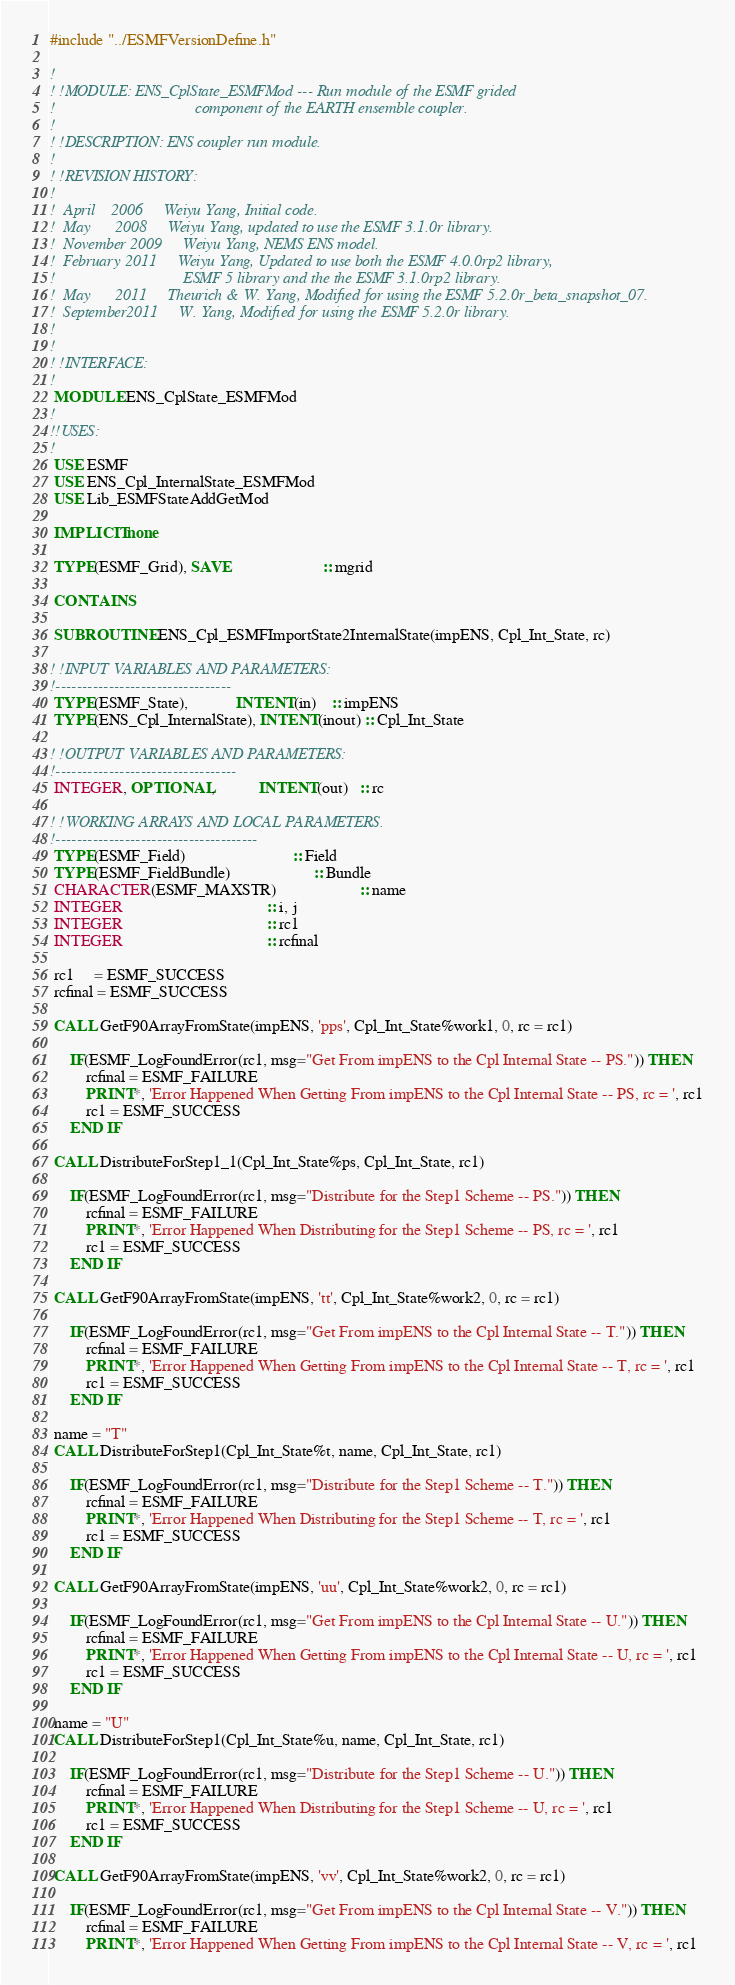Convert code to text. <code><loc_0><loc_0><loc_500><loc_500><_FORTRAN_>#include "../ESMFVersionDefine.h"

!
! !MODULE: ENS_CplState_ESMFMod --- Run module of the ESMF grided
!                                   component of the EARTH ensemble coupler.
!
! !DESCRIPTION: ENS coupler run module.
!
! !REVISION HISTORY:
!
!  April    2006     Weiyu Yang, Initial code.
!  May      2008     Weiyu Yang, updated to use the ESMF 3.1.0r library.
!  November 2009     Weiyu Yang, NEMS ENS model.
!  February 2011     Weiyu Yang, Updated to use both the ESMF 4.0.0rp2 library,
!                                ESMF 5 library and the the ESMF 3.1.0rp2 library.
!  May      2011     Theurich & W. Yang, Modified for using the ESMF 5.2.0r_beta_snapshot_07.
!  September2011     W. Yang, Modified for using the ESMF 5.2.0r library.
!
!
! !INTERFACE:
!
 MODULE ENS_CplState_ESMFMod
!
!!USES:
!
 USE ESMF
 USE ENS_Cpl_InternalState_ESMFMod
 USE Lib_ESMFStateAddGetMod

 IMPLICIT none

 TYPE(ESMF_Grid), SAVE                       :: mgrid

 CONTAINS

 SUBROUTINE ENS_Cpl_ESMFImportState2InternalState(impENS, Cpl_Int_State, rc)

! !INPUT VARIABLES AND PARAMETERS:
!---------------------------------
 TYPE(ESMF_State),            INTENT(in)    :: impENS
 TYPE(ENS_Cpl_InternalState), INTENT(inout) :: Cpl_Int_State

! !OUTPUT VARIABLES AND PARAMETERS:
!----------------------------------
 INTEGER, OPTIONAL,           INTENT(out)   :: rc

! !WORKING ARRAYS AND LOCAL PARAMETERS.
!--------------------------------------
 TYPE(ESMF_Field)                           :: Field
 TYPE(ESMF_FieldBundle)                     :: Bundle
 CHARACTER(ESMF_MAXSTR)                     :: name
 INTEGER                                    :: i, j
 INTEGER                                    :: rc1
 INTEGER                                    :: rcfinal

 rc1     = ESMF_SUCCESS
 rcfinal = ESMF_SUCCESS

 CALL GetF90ArrayFromState(impENS, 'pps', Cpl_Int_State%work1, 0, rc = rc1)

     IF(ESMF_LogFoundError(rc1, msg="Get From impENS to the Cpl Internal State -- PS.")) THEN
         rcfinal = ESMF_FAILURE
         PRINT*, 'Error Happened When Getting From impENS to the Cpl Internal State -- PS, rc = ', rc1
         rc1 = ESMF_SUCCESS
     END IF

 CALL DistributeForStep1_1(Cpl_Int_State%ps, Cpl_Int_State, rc1)

     IF(ESMF_LogFoundError(rc1, msg="Distribute for the Step1 Scheme -- PS.")) THEN
         rcfinal = ESMF_FAILURE
         PRINT*, 'Error Happened When Distributing for the Step1 Scheme -- PS, rc = ', rc1
         rc1 = ESMF_SUCCESS
     END IF

 CALL GetF90ArrayFromState(impENS, 'tt', Cpl_Int_State%work2, 0, rc = rc1)

     IF(ESMF_LogFoundError(rc1, msg="Get From impENS to the Cpl Internal State -- T.")) THEN
         rcfinal = ESMF_FAILURE
         PRINT*, 'Error Happened When Getting From impENS to the Cpl Internal State -- T, rc = ', rc1
         rc1 = ESMF_SUCCESS
     END IF

 name = "T"
 CALL DistributeForStep1(Cpl_Int_State%t, name, Cpl_Int_State, rc1)

     IF(ESMF_LogFoundError(rc1, msg="Distribute for the Step1 Scheme -- T.")) THEN
         rcfinal = ESMF_FAILURE
         PRINT*, 'Error Happened When Distributing for the Step1 Scheme -- T, rc = ', rc1
         rc1 = ESMF_SUCCESS
     END IF

 CALL GetF90ArrayFromState(impENS, 'uu', Cpl_Int_State%work2, 0, rc = rc1)

     IF(ESMF_LogFoundError(rc1, msg="Get From impENS to the Cpl Internal State -- U.")) THEN
         rcfinal = ESMF_FAILURE
         PRINT*, 'Error Happened When Getting From impENS to the Cpl Internal State -- U, rc = ', rc1
         rc1 = ESMF_SUCCESS
     END IF

 name = "U"
 CALL DistributeForStep1(Cpl_Int_State%u, name, Cpl_Int_State, rc1)

     IF(ESMF_LogFoundError(rc1, msg="Distribute for the Step1 Scheme -- U.")) THEN
         rcfinal = ESMF_FAILURE
         PRINT*, 'Error Happened When Distributing for the Step1 Scheme -- U, rc = ', rc1
         rc1 = ESMF_SUCCESS
     END IF

 CALL GetF90ArrayFromState(impENS, 'vv', Cpl_Int_State%work2, 0, rc = rc1)

     IF(ESMF_LogFoundError(rc1, msg="Get From impENS to the Cpl Internal State -- V.")) THEN
         rcfinal = ESMF_FAILURE
         PRINT*, 'Error Happened When Getting From impENS to the Cpl Internal State -- V, rc = ', rc1</code> 